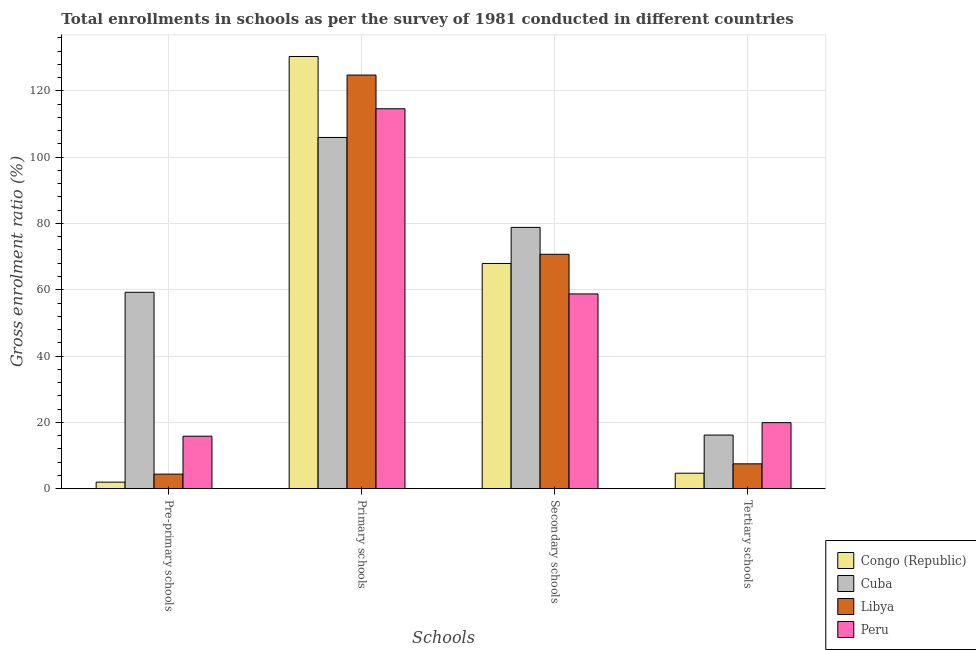How many groups of bars are there?
Ensure brevity in your answer.  4. Are the number of bars per tick equal to the number of legend labels?
Your response must be concise. Yes. How many bars are there on the 1st tick from the left?
Provide a succinct answer. 4. How many bars are there on the 3rd tick from the right?
Make the answer very short. 4. What is the label of the 1st group of bars from the left?
Your answer should be very brief. Pre-primary schools. What is the gross enrolment ratio in pre-primary schools in Congo (Republic)?
Your response must be concise. 1.98. Across all countries, what is the maximum gross enrolment ratio in tertiary schools?
Your answer should be very brief. 19.92. Across all countries, what is the minimum gross enrolment ratio in pre-primary schools?
Offer a terse response. 1.98. In which country was the gross enrolment ratio in secondary schools maximum?
Offer a terse response. Cuba. In which country was the gross enrolment ratio in primary schools minimum?
Offer a terse response. Cuba. What is the total gross enrolment ratio in tertiary schools in the graph?
Give a very brief answer. 48.25. What is the difference between the gross enrolment ratio in pre-primary schools in Peru and that in Congo (Republic)?
Your answer should be very brief. 13.86. What is the difference between the gross enrolment ratio in primary schools in Congo (Republic) and the gross enrolment ratio in secondary schools in Peru?
Offer a very short reply. 71.63. What is the average gross enrolment ratio in tertiary schools per country?
Provide a succinct answer. 12.06. What is the difference between the gross enrolment ratio in tertiary schools and gross enrolment ratio in secondary schools in Congo (Republic)?
Offer a very short reply. -63.27. In how many countries, is the gross enrolment ratio in primary schools greater than 104 %?
Offer a very short reply. 4. What is the ratio of the gross enrolment ratio in pre-primary schools in Congo (Republic) to that in Libya?
Keep it short and to the point. 0.45. Is the gross enrolment ratio in secondary schools in Cuba less than that in Libya?
Provide a short and direct response. No. Is the difference between the gross enrolment ratio in tertiary schools in Congo (Republic) and Libya greater than the difference between the gross enrolment ratio in secondary schools in Congo (Republic) and Libya?
Make the answer very short. No. What is the difference between the highest and the second highest gross enrolment ratio in pre-primary schools?
Provide a succinct answer. 43.41. What is the difference between the highest and the lowest gross enrolment ratio in primary schools?
Your answer should be compact. 24.43. What does the 1st bar from the left in Secondary schools represents?
Provide a succinct answer. Congo (Republic). Are all the bars in the graph horizontal?
Give a very brief answer. No. How many countries are there in the graph?
Your response must be concise. 4. Are the values on the major ticks of Y-axis written in scientific E-notation?
Offer a very short reply. No. Does the graph contain any zero values?
Provide a short and direct response. No. What is the title of the graph?
Keep it short and to the point. Total enrollments in schools as per the survey of 1981 conducted in different countries. What is the label or title of the X-axis?
Give a very brief answer. Schools. What is the Gross enrolment ratio (%) of Congo (Republic) in Pre-primary schools?
Provide a succinct answer. 1.98. What is the Gross enrolment ratio (%) of Cuba in Pre-primary schools?
Provide a succinct answer. 59.24. What is the Gross enrolment ratio (%) in Libya in Pre-primary schools?
Offer a terse response. 4.39. What is the Gross enrolment ratio (%) in Peru in Pre-primary schools?
Your answer should be very brief. 15.83. What is the Gross enrolment ratio (%) in Congo (Republic) in Primary schools?
Provide a succinct answer. 130.37. What is the Gross enrolment ratio (%) in Cuba in Primary schools?
Your answer should be very brief. 105.95. What is the Gross enrolment ratio (%) in Libya in Primary schools?
Make the answer very short. 124.77. What is the Gross enrolment ratio (%) of Peru in Primary schools?
Offer a very short reply. 114.61. What is the Gross enrolment ratio (%) of Congo (Republic) in Secondary schools?
Your response must be concise. 67.94. What is the Gross enrolment ratio (%) of Cuba in Secondary schools?
Your answer should be very brief. 78.82. What is the Gross enrolment ratio (%) of Libya in Secondary schools?
Your answer should be very brief. 70.7. What is the Gross enrolment ratio (%) in Peru in Secondary schools?
Keep it short and to the point. 58.74. What is the Gross enrolment ratio (%) in Congo (Republic) in Tertiary schools?
Ensure brevity in your answer.  4.67. What is the Gross enrolment ratio (%) in Cuba in Tertiary schools?
Your response must be concise. 16.17. What is the Gross enrolment ratio (%) in Libya in Tertiary schools?
Ensure brevity in your answer.  7.49. What is the Gross enrolment ratio (%) of Peru in Tertiary schools?
Ensure brevity in your answer.  19.92. Across all Schools, what is the maximum Gross enrolment ratio (%) in Congo (Republic)?
Your answer should be compact. 130.37. Across all Schools, what is the maximum Gross enrolment ratio (%) of Cuba?
Provide a short and direct response. 105.95. Across all Schools, what is the maximum Gross enrolment ratio (%) of Libya?
Your response must be concise. 124.77. Across all Schools, what is the maximum Gross enrolment ratio (%) of Peru?
Your answer should be compact. 114.61. Across all Schools, what is the minimum Gross enrolment ratio (%) of Congo (Republic)?
Your response must be concise. 1.98. Across all Schools, what is the minimum Gross enrolment ratio (%) in Cuba?
Your response must be concise. 16.17. Across all Schools, what is the minimum Gross enrolment ratio (%) in Libya?
Give a very brief answer. 4.39. Across all Schools, what is the minimum Gross enrolment ratio (%) of Peru?
Offer a very short reply. 15.83. What is the total Gross enrolment ratio (%) of Congo (Republic) in the graph?
Your answer should be compact. 204.95. What is the total Gross enrolment ratio (%) in Cuba in the graph?
Make the answer very short. 260.18. What is the total Gross enrolment ratio (%) of Libya in the graph?
Offer a very short reply. 207.36. What is the total Gross enrolment ratio (%) in Peru in the graph?
Keep it short and to the point. 209.1. What is the difference between the Gross enrolment ratio (%) in Congo (Republic) in Pre-primary schools and that in Primary schools?
Your response must be concise. -128.4. What is the difference between the Gross enrolment ratio (%) of Cuba in Pre-primary schools and that in Primary schools?
Ensure brevity in your answer.  -46.7. What is the difference between the Gross enrolment ratio (%) in Libya in Pre-primary schools and that in Primary schools?
Offer a terse response. -120.38. What is the difference between the Gross enrolment ratio (%) in Peru in Pre-primary schools and that in Primary schools?
Keep it short and to the point. -98.78. What is the difference between the Gross enrolment ratio (%) of Congo (Republic) in Pre-primary schools and that in Secondary schools?
Provide a succinct answer. -65.96. What is the difference between the Gross enrolment ratio (%) of Cuba in Pre-primary schools and that in Secondary schools?
Your response must be concise. -19.57. What is the difference between the Gross enrolment ratio (%) in Libya in Pre-primary schools and that in Secondary schools?
Offer a terse response. -66.31. What is the difference between the Gross enrolment ratio (%) of Peru in Pre-primary schools and that in Secondary schools?
Keep it short and to the point. -42.91. What is the difference between the Gross enrolment ratio (%) of Congo (Republic) in Pre-primary schools and that in Tertiary schools?
Offer a very short reply. -2.69. What is the difference between the Gross enrolment ratio (%) in Cuba in Pre-primary schools and that in Tertiary schools?
Provide a succinct answer. 43.07. What is the difference between the Gross enrolment ratio (%) of Libya in Pre-primary schools and that in Tertiary schools?
Ensure brevity in your answer.  -3.1. What is the difference between the Gross enrolment ratio (%) in Peru in Pre-primary schools and that in Tertiary schools?
Ensure brevity in your answer.  -4.09. What is the difference between the Gross enrolment ratio (%) in Congo (Republic) in Primary schools and that in Secondary schools?
Keep it short and to the point. 62.44. What is the difference between the Gross enrolment ratio (%) in Cuba in Primary schools and that in Secondary schools?
Offer a very short reply. 27.13. What is the difference between the Gross enrolment ratio (%) of Libya in Primary schools and that in Secondary schools?
Offer a very short reply. 54.07. What is the difference between the Gross enrolment ratio (%) in Peru in Primary schools and that in Secondary schools?
Offer a very short reply. 55.86. What is the difference between the Gross enrolment ratio (%) of Congo (Republic) in Primary schools and that in Tertiary schools?
Provide a short and direct response. 125.71. What is the difference between the Gross enrolment ratio (%) in Cuba in Primary schools and that in Tertiary schools?
Ensure brevity in your answer.  89.77. What is the difference between the Gross enrolment ratio (%) of Libya in Primary schools and that in Tertiary schools?
Your response must be concise. 117.28. What is the difference between the Gross enrolment ratio (%) in Peru in Primary schools and that in Tertiary schools?
Your response must be concise. 94.69. What is the difference between the Gross enrolment ratio (%) in Congo (Republic) in Secondary schools and that in Tertiary schools?
Your answer should be compact. 63.27. What is the difference between the Gross enrolment ratio (%) in Cuba in Secondary schools and that in Tertiary schools?
Offer a very short reply. 62.64. What is the difference between the Gross enrolment ratio (%) in Libya in Secondary schools and that in Tertiary schools?
Give a very brief answer. 63.21. What is the difference between the Gross enrolment ratio (%) of Peru in Secondary schools and that in Tertiary schools?
Provide a short and direct response. 38.83. What is the difference between the Gross enrolment ratio (%) in Congo (Republic) in Pre-primary schools and the Gross enrolment ratio (%) in Cuba in Primary schools?
Ensure brevity in your answer.  -103.97. What is the difference between the Gross enrolment ratio (%) of Congo (Republic) in Pre-primary schools and the Gross enrolment ratio (%) of Libya in Primary schools?
Your answer should be very brief. -122.8. What is the difference between the Gross enrolment ratio (%) in Congo (Republic) in Pre-primary schools and the Gross enrolment ratio (%) in Peru in Primary schools?
Provide a succinct answer. -112.63. What is the difference between the Gross enrolment ratio (%) of Cuba in Pre-primary schools and the Gross enrolment ratio (%) of Libya in Primary schools?
Provide a short and direct response. -65.53. What is the difference between the Gross enrolment ratio (%) in Cuba in Pre-primary schools and the Gross enrolment ratio (%) in Peru in Primary schools?
Provide a succinct answer. -55.36. What is the difference between the Gross enrolment ratio (%) in Libya in Pre-primary schools and the Gross enrolment ratio (%) in Peru in Primary schools?
Your response must be concise. -110.22. What is the difference between the Gross enrolment ratio (%) of Congo (Republic) in Pre-primary schools and the Gross enrolment ratio (%) of Cuba in Secondary schools?
Make the answer very short. -76.84. What is the difference between the Gross enrolment ratio (%) of Congo (Republic) in Pre-primary schools and the Gross enrolment ratio (%) of Libya in Secondary schools?
Your answer should be very brief. -68.73. What is the difference between the Gross enrolment ratio (%) in Congo (Republic) in Pre-primary schools and the Gross enrolment ratio (%) in Peru in Secondary schools?
Offer a terse response. -56.77. What is the difference between the Gross enrolment ratio (%) of Cuba in Pre-primary schools and the Gross enrolment ratio (%) of Libya in Secondary schools?
Keep it short and to the point. -11.46. What is the difference between the Gross enrolment ratio (%) in Cuba in Pre-primary schools and the Gross enrolment ratio (%) in Peru in Secondary schools?
Make the answer very short. 0.5. What is the difference between the Gross enrolment ratio (%) in Libya in Pre-primary schools and the Gross enrolment ratio (%) in Peru in Secondary schools?
Your answer should be very brief. -54.36. What is the difference between the Gross enrolment ratio (%) in Congo (Republic) in Pre-primary schools and the Gross enrolment ratio (%) in Cuba in Tertiary schools?
Your response must be concise. -14.2. What is the difference between the Gross enrolment ratio (%) in Congo (Republic) in Pre-primary schools and the Gross enrolment ratio (%) in Libya in Tertiary schools?
Your answer should be very brief. -5.52. What is the difference between the Gross enrolment ratio (%) in Congo (Republic) in Pre-primary schools and the Gross enrolment ratio (%) in Peru in Tertiary schools?
Give a very brief answer. -17.94. What is the difference between the Gross enrolment ratio (%) in Cuba in Pre-primary schools and the Gross enrolment ratio (%) in Libya in Tertiary schools?
Ensure brevity in your answer.  51.75. What is the difference between the Gross enrolment ratio (%) in Cuba in Pre-primary schools and the Gross enrolment ratio (%) in Peru in Tertiary schools?
Your answer should be very brief. 39.33. What is the difference between the Gross enrolment ratio (%) of Libya in Pre-primary schools and the Gross enrolment ratio (%) of Peru in Tertiary schools?
Your response must be concise. -15.53. What is the difference between the Gross enrolment ratio (%) in Congo (Republic) in Primary schools and the Gross enrolment ratio (%) in Cuba in Secondary schools?
Your answer should be very brief. 51.56. What is the difference between the Gross enrolment ratio (%) of Congo (Republic) in Primary schools and the Gross enrolment ratio (%) of Libya in Secondary schools?
Your response must be concise. 59.67. What is the difference between the Gross enrolment ratio (%) in Congo (Republic) in Primary schools and the Gross enrolment ratio (%) in Peru in Secondary schools?
Your answer should be very brief. 71.63. What is the difference between the Gross enrolment ratio (%) of Cuba in Primary schools and the Gross enrolment ratio (%) of Libya in Secondary schools?
Your response must be concise. 35.24. What is the difference between the Gross enrolment ratio (%) of Cuba in Primary schools and the Gross enrolment ratio (%) of Peru in Secondary schools?
Offer a terse response. 47.2. What is the difference between the Gross enrolment ratio (%) of Libya in Primary schools and the Gross enrolment ratio (%) of Peru in Secondary schools?
Provide a succinct answer. 66.03. What is the difference between the Gross enrolment ratio (%) of Congo (Republic) in Primary schools and the Gross enrolment ratio (%) of Cuba in Tertiary schools?
Offer a very short reply. 114.2. What is the difference between the Gross enrolment ratio (%) of Congo (Republic) in Primary schools and the Gross enrolment ratio (%) of Libya in Tertiary schools?
Provide a succinct answer. 122.88. What is the difference between the Gross enrolment ratio (%) in Congo (Republic) in Primary schools and the Gross enrolment ratio (%) in Peru in Tertiary schools?
Ensure brevity in your answer.  110.46. What is the difference between the Gross enrolment ratio (%) of Cuba in Primary schools and the Gross enrolment ratio (%) of Libya in Tertiary schools?
Make the answer very short. 98.45. What is the difference between the Gross enrolment ratio (%) of Cuba in Primary schools and the Gross enrolment ratio (%) of Peru in Tertiary schools?
Give a very brief answer. 86.03. What is the difference between the Gross enrolment ratio (%) of Libya in Primary schools and the Gross enrolment ratio (%) of Peru in Tertiary schools?
Offer a terse response. 104.85. What is the difference between the Gross enrolment ratio (%) in Congo (Republic) in Secondary schools and the Gross enrolment ratio (%) in Cuba in Tertiary schools?
Keep it short and to the point. 51.76. What is the difference between the Gross enrolment ratio (%) of Congo (Republic) in Secondary schools and the Gross enrolment ratio (%) of Libya in Tertiary schools?
Keep it short and to the point. 60.44. What is the difference between the Gross enrolment ratio (%) in Congo (Republic) in Secondary schools and the Gross enrolment ratio (%) in Peru in Tertiary schools?
Offer a terse response. 48.02. What is the difference between the Gross enrolment ratio (%) of Cuba in Secondary schools and the Gross enrolment ratio (%) of Libya in Tertiary schools?
Make the answer very short. 71.32. What is the difference between the Gross enrolment ratio (%) of Cuba in Secondary schools and the Gross enrolment ratio (%) of Peru in Tertiary schools?
Make the answer very short. 58.9. What is the difference between the Gross enrolment ratio (%) of Libya in Secondary schools and the Gross enrolment ratio (%) of Peru in Tertiary schools?
Keep it short and to the point. 50.79. What is the average Gross enrolment ratio (%) in Congo (Republic) per Schools?
Provide a short and direct response. 51.24. What is the average Gross enrolment ratio (%) of Cuba per Schools?
Your answer should be compact. 65.04. What is the average Gross enrolment ratio (%) in Libya per Schools?
Ensure brevity in your answer.  51.84. What is the average Gross enrolment ratio (%) in Peru per Schools?
Keep it short and to the point. 52.28. What is the difference between the Gross enrolment ratio (%) of Congo (Republic) and Gross enrolment ratio (%) of Cuba in Pre-primary schools?
Ensure brevity in your answer.  -57.27. What is the difference between the Gross enrolment ratio (%) in Congo (Republic) and Gross enrolment ratio (%) in Libya in Pre-primary schools?
Offer a very short reply. -2.41. What is the difference between the Gross enrolment ratio (%) in Congo (Republic) and Gross enrolment ratio (%) in Peru in Pre-primary schools?
Your answer should be compact. -13.86. What is the difference between the Gross enrolment ratio (%) of Cuba and Gross enrolment ratio (%) of Libya in Pre-primary schools?
Your response must be concise. 54.85. What is the difference between the Gross enrolment ratio (%) in Cuba and Gross enrolment ratio (%) in Peru in Pre-primary schools?
Ensure brevity in your answer.  43.41. What is the difference between the Gross enrolment ratio (%) of Libya and Gross enrolment ratio (%) of Peru in Pre-primary schools?
Your response must be concise. -11.44. What is the difference between the Gross enrolment ratio (%) of Congo (Republic) and Gross enrolment ratio (%) of Cuba in Primary schools?
Offer a terse response. 24.43. What is the difference between the Gross enrolment ratio (%) in Congo (Republic) and Gross enrolment ratio (%) in Libya in Primary schools?
Keep it short and to the point. 5.6. What is the difference between the Gross enrolment ratio (%) in Congo (Republic) and Gross enrolment ratio (%) in Peru in Primary schools?
Provide a short and direct response. 15.77. What is the difference between the Gross enrolment ratio (%) of Cuba and Gross enrolment ratio (%) of Libya in Primary schools?
Provide a succinct answer. -18.82. What is the difference between the Gross enrolment ratio (%) in Cuba and Gross enrolment ratio (%) in Peru in Primary schools?
Give a very brief answer. -8.66. What is the difference between the Gross enrolment ratio (%) in Libya and Gross enrolment ratio (%) in Peru in Primary schools?
Keep it short and to the point. 10.16. What is the difference between the Gross enrolment ratio (%) in Congo (Republic) and Gross enrolment ratio (%) in Cuba in Secondary schools?
Provide a short and direct response. -10.88. What is the difference between the Gross enrolment ratio (%) of Congo (Republic) and Gross enrolment ratio (%) of Libya in Secondary schools?
Offer a very short reply. -2.77. What is the difference between the Gross enrolment ratio (%) of Congo (Republic) and Gross enrolment ratio (%) of Peru in Secondary schools?
Your response must be concise. 9.19. What is the difference between the Gross enrolment ratio (%) of Cuba and Gross enrolment ratio (%) of Libya in Secondary schools?
Your answer should be very brief. 8.11. What is the difference between the Gross enrolment ratio (%) in Cuba and Gross enrolment ratio (%) in Peru in Secondary schools?
Give a very brief answer. 20.07. What is the difference between the Gross enrolment ratio (%) of Libya and Gross enrolment ratio (%) of Peru in Secondary schools?
Give a very brief answer. 11.96. What is the difference between the Gross enrolment ratio (%) of Congo (Republic) and Gross enrolment ratio (%) of Cuba in Tertiary schools?
Provide a short and direct response. -11.51. What is the difference between the Gross enrolment ratio (%) of Congo (Republic) and Gross enrolment ratio (%) of Libya in Tertiary schools?
Your answer should be very brief. -2.83. What is the difference between the Gross enrolment ratio (%) in Congo (Republic) and Gross enrolment ratio (%) in Peru in Tertiary schools?
Offer a very short reply. -15.25. What is the difference between the Gross enrolment ratio (%) of Cuba and Gross enrolment ratio (%) of Libya in Tertiary schools?
Offer a terse response. 8.68. What is the difference between the Gross enrolment ratio (%) of Cuba and Gross enrolment ratio (%) of Peru in Tertiary schools?
Your answer should be compact. -3.74. What is the difference between the Gross enrolment ratio (%) of Libya and Gross enrolment ratio (%) of Peru in Tertiary schools?
Your answer should be very brief. -12.42. What is the ratio of the Gross enrolment ratio (%) of Congo (Republic) in Pre-primary schools to that in Primary schools?
Give a very brief answer. 0.02. What is the ratio of the Gross enrolment ratio (%) in Cuba in Pre-primary schools to that in Primary schools?
Offer a terse response. 0.56. What is the ratio of the Gross enrolment ratio (%) in Libya in Pre-primary schools to that in Primary schools?
Provide a short and direct response. 0.04. What is the ratio of the Gross enrolment ratio (%) of Peru in Pre-primary schools to that in Primary schools?
Make the answer very short. 0.14. What is the ratio of the Gross enrolment ratio (%) in Congo (Republic) in Pre-primary schools to that in Secondary schools?
Offer a terse response. 0.03. What is the ratio of the Gross enrolment ratio (%) of Cuba in Pre-primary schools to that in Secondary schools?
Provide a short and direct response. 0.75. What is the ratio of the Gross enrolment ratio (%) in Libya in Pre-primary schools to that in Secondary schools?
Ensure brevity in your answer.  0.06. What is the ratio of the Gross enrolment ratio (%) of Peru in Pre-primary schools to that in Secondary schools?
Give a very brief answer. 0.27. What is the ratio of the Gross enrolment ratio (%) of Congo (Republic) in Pre-primary schools to that in Tertiary schools?
Provide a short and direct response. 0.42. What is the ratio of the Gross enrolment ratio (%) in Cuba in Pre-primary schools to that in Tertiary schools?
Offer a very short reply. 3.66. What is the ratio of the Gross enrolment ratio (%) of Libya in Pre-primary schools to that in Tertiary schools?
Offer a terse response. 0.59. What is the ratio of the Gross enrolment ratio (%) of Peru in Pre-primary schools to that in Tertiary schools?
Ensure brevity in your answer.  0.79. What is the ratio of the Gross enrolment ratio (%) of Congo (Republic) in Primary schools to that in Secondary schools?
Offer a terse response. 1.92. What is the ratio of the Gross enrolment ratio (%) in Cuba in Primary schools to that in Secondary schools?
Offer a terse response. 1.34. What is the ratio of the Gross enrolment ratio (%) of Libya in Primary schools to that in Secondary schools?
Your response must be concise. 1.76. What is the ratio of the Gross enrolment ratio (%) of Peru in Primary schools to that in Secondary schools?
Your answer should be very brief. 1.95. What is the ratio of the Gross enrolment ratio (%) of Congo (Republic) in Primary schools to that in Tertiary schools?
Ensure brevity in your answer.  27.94. What is the ratio of the Gross enrolment ratio (%) in Cuba in Primary schools to that in Tertiary schools?
Give a very brief answer. 6.55. What is the ratio of the Gross enrolment ratio (%) in Libya in Primary schools to that in Tertiary schools?
Offer a terse response. 16.65. What is the ratio of the Gross enrolment ratio (%) of Peru in Primary schools to that in Tertiary schools?
Ensure brevity in your answer.  5.75. What is the ratio of the Gross enrolment ratio (%) in Congo (Republic) in Secondary schools to that in Tertiary schools?
Provide a succinct answer. 14.56. What is the ratio of the Gross enrolment ratio (%) in Cuba in Secondary schools to that in Tertiary schools?
Provide a short and direct response. 4.87. What is the ratio of the Gross enrolment ratio (%) of Libya in Secondary schools to that in Tertiary schools?
Offer a terse response. 9.44. What is the ratio of the Gross enrolment ratio (%) in Peru in Secondary schools to that in Tertiary schools?
Your answer should be very brief. 2.95. What is the difference between the highest and the second highest Gross enrolment ratio (%) in Congo (Republic)?
Offer a terse response. 62.44. What is the difference between the highest and the second highest Gross enrolment ratio (%) of Cuba?
Provide a short and direct response. 27.13. What is the difference between the highest and the second highest Gross enrolment ratio (%) of Libya?
Give a very brief answer. 54.07. What is the difference between the highest and the second highest Gross enrolment ratio (%) in Peru?
Your response must be concise. 55.86. What is the difference between the highest and the lowest Gross enrolment ratio (%) of Congo (Republic)?
Keep it short and to the point. 128.4. What is the difference between the highest and the lowest Gross enrolment ratio (%) in Cuba?
Your answer should be compact. 89.77. What is the difference between the highest and the lowest Gross enrolment ratio (%) of Libya?
Your answer should be compact. 120.38. What is the difference between the highest and the lowest Gross enrolment ratio (%) of Peru?
Offer a very short reply. 98.78. 